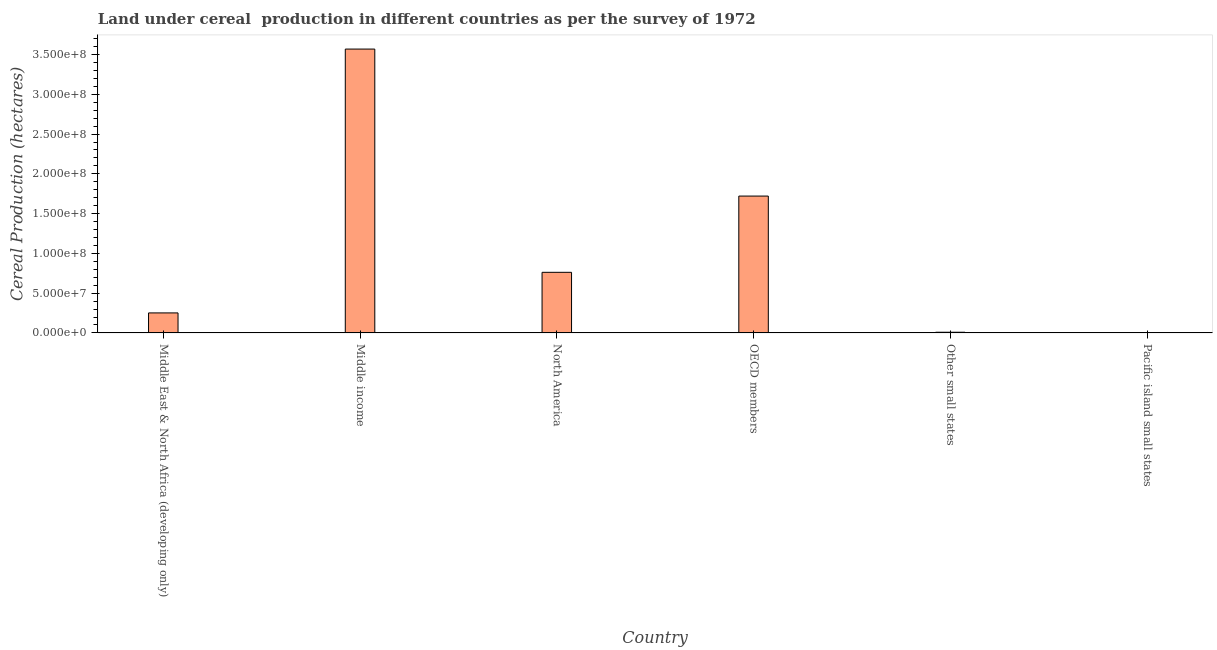Does the graph contain any zero values?
Give a very brief answer. No. Does the graph contain grids?
Offer a terse response. No. What is the title of the graph?
Offer a terse response. Land under cereal  production in different countries as per the survey of 1972. What is the label or title of the Y-axis?
Keep it short and to the point. Cereal Production (hectares). What is the land under cereal production in Middle East & North Africa (developing only)?
Make the answer very short. 2.52e+07. Across all countries, what is the maximum land under cereal production?
Provide a succinct answer. 3.57e+08. Across all countries, what is the minimum land under cereal production?
Keep it short and to the point. 1.06e+04. In which country was the land under cereal production maximum?
Give a very brief answer. Middle income. In which country was the land under cereal production minimum?
Make the answer very short. Pacific island small states. What is the sum of the land under cereal production?
Provide a short and direct response. 6.31e+08. What is the difference between the land under cereal production in OECD members and Pacific island small states?
Offer a terse response. 1.72e+08. What is the average land under cereal production per country?
Your response must be concise. 1.05e+08. What is the median land under cereal production?
Make the answer very short. 5.07e+07. In how many countries, is the land under cereal production greater than 270000000 hectares?
Make the answer very short. 1. What is the ratio of the land under cereal production in Middle East & North Africa (developing only) to that in Middle income?
Your answer should be very brief. 0.07. What is the difference between the highest and the second highest land under cereal production?
Your answer should be very brief. 1.85e+08. What is the difference between the highest and the lowest land under cereal production?
Keep it short and to the point. 3.57e+08. In how many countries, is the land under cereal production greater than the average land under cereal production taken over all countries?
Give a very brief answer. 2. Are all the bars in the graph horizontal?
Your answer should be very brief. No. How many countries are there in the graph?
Offer a terse response. 6. Are the values on the major ticks of Y-axis written in scientific E-notation?
Provide a succinct answer. Yes. What is the Cereal Production (hectares) in Middle East & North Africa (developing only)?
Provide a succinct answer. 2.52e+07. What is the Cereal Production (hectares) in Middle income?
Keep it short and to the point. 3.57e+08. What is the Cereal Production (hectares) of North America?
Keep it short and to the point. 7.62e+07. What is the Cereal Production (hectares) in OECD members?
Your response must be concise. 1.72e+08. What is the Cereal Production (hectares) of Other small states?
Ensure brevity in your answer.  8.81e+05. What is the Cereal Production (hectares) in Pacific island small states?
Your answer should be very brief. 1.06e+04. What is the difference between the Cereal Production (hectares) in Middle East & North Africa (developing only) and Middle income?
Your answer should be very brief. -3.32e+08. What is the difference between the Cereal Production (hectares) in Middle East & North Africa (developing only) and North America?
Provide a short and direct response. -5.10e+07. What is the difference between the Cereal Production (hectares) in Middle East & North Africa (developing only) and OECD members?
Your response must be concise. -1.47e+08. What is the difference between the Cereal Production (hectares) in Middle East & North Africa (developing only) and Other small states?
Keep it short and to the point. 2.43e+07. What is the difference between the Cereal Production (hectares) in Middle East & North Africa (developing only) and Pacific island small states?
Provide a short and direct response. 2.52e+07. What is the difference between the Cereal Production (hectares) in Middle income and North America?
Ensure brevity in your answer.  2.81e+08. What is the difference between the Cereal Production (hectares) in Middle income and OECD members?
Offer a very short reply. 1.85e+08. What is the difference between the Cereal Production (hectares) in Middle income and Other small states?
Make the answer very short. 3.56e+08. What is the difference between the Cereal Production (hectares) in Middle income and Pacific island small states?
Keep it short and to the point. 3.57e+08. What is the difference between the Cereal Production (hectares) in North America and OECD members?
Offer a terse response. -9.58e+07. What is the difference between the Cereal Production (hectares) in North America and Other small states?
Your answer should be compact. 7.53e+07. What is the difference between the Cereal Production (hectares) in North America and Pacific island small states?
Ensure brevity in your answer.  7.62e+07. What is the difference between the Cereal Production (hectares) in OECD members and Other small states?
Offer a very short reply. 1.71e+08. What is the difference between the Cereal Production (hectares) in OECD members and Pacific island small states?
Keep it short and to the point. 1.72e+08. What is the difference between the Cereal Production (hectares) in Other small states and Pacific island small states?
Ensure brevity in your answer.  8.70e+05. What is the ratio of the Cereal Production (hectares) in Middle East & North Africa (developing only) to that in Middle income?
Make the answer very short. 0.07. What is the ratio of the Cereal Production (hectares) in Middle East & North Africa (developing only) to that in North America?
Provide a short and direct response. 0.33. What is the ratio of the Cereal Production (hectares) in Middle East & North Africa (developing only) to that in OECD members?
Your answer should be compact. 0.15. What is the ratio of the Cereal Production (hectares) in Middle East & North Africa (developing only) to that in Other small states?
Provide a short and direct response. 28.59. What is the ratio of the Cereal Production (hectares) in Middle East & North Africa (developing only) to that in Pacific island small states?
Give a very brief answer. 2366.87. What is the ratio of the Cereal Production (hectares) in Middle income to that in North America?
Your answer should be compact. 4.68. What is the ratio of the Cereal Production (hectares) in Middle income to that in OECD members?
Offer a very short reply. 2.07. What is the ratio of the Cereal Production (hectares) in Middle income to that in Other small states?
Provide a short and direct response. 405.17. What is the ratio of the Cereal Production (hectares) in Middle income to that in Pacific island small states?
Your answer should be compact. 3.35e+04. What is the ratio of the Cereal Production (hectares) in North America to that in OECD members?
Your answer should be compact. 0.44. What is the ratio of the Cereal Production (hectares) in North America to that in Other small states?
Offer a very short reply. 86.53. What is the ratio of the Cereal Production (hectares) in North America to that in Pacific island small states?
Your answer should be very brief. 7162.82. What is the ratio of the Cereal Production (hectares) in OECD members to that in Other small states?
Provide a short and direct response. 195.35. What is the ratio of the Cereal Production (hectares) in OECD members to that in Pacific island small states?
Keep it short and to the point. 1.62e+04. What is the ratio of the Cereal Production (hectares) in Other small states to that in Pacific island small states?
Provide a short and direct response. 82.78. 